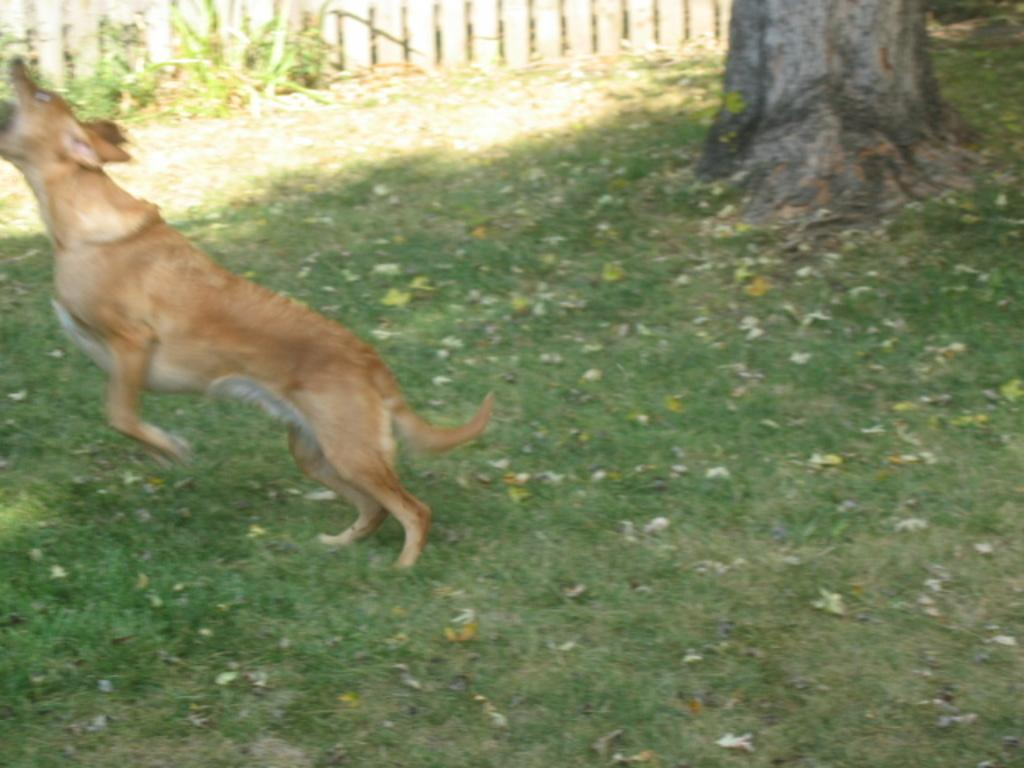What animal can be seen in the image? There is a dog in the image. What is the dog doing in the image? The dog is jumping on the grass. What can be seen in the background of the image? There is a tree, plants, and a wooden fence in the background of the image. How does the dog increase the volume of the pump in the image? There is no pump present in the image, and the dog is not interacting with any object related to increasing volume. 